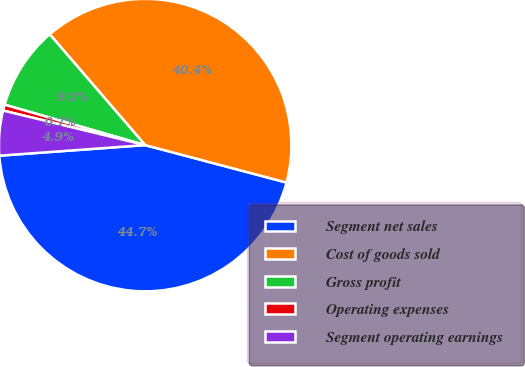Convert chart. <chart><loc_0><loc_0><loc_500><loc_500><pie_chart><fcel>Segment net sales<fcel>Cost of goods sold<fcel>Gross profit<fcel>Operating expenses<fcel>Segment operating earnings<nl><fcel>44.73%<fcel>40.44%<fcel>9.23%<fcel>0.66%<fcel>4.95%<nl></chart> 